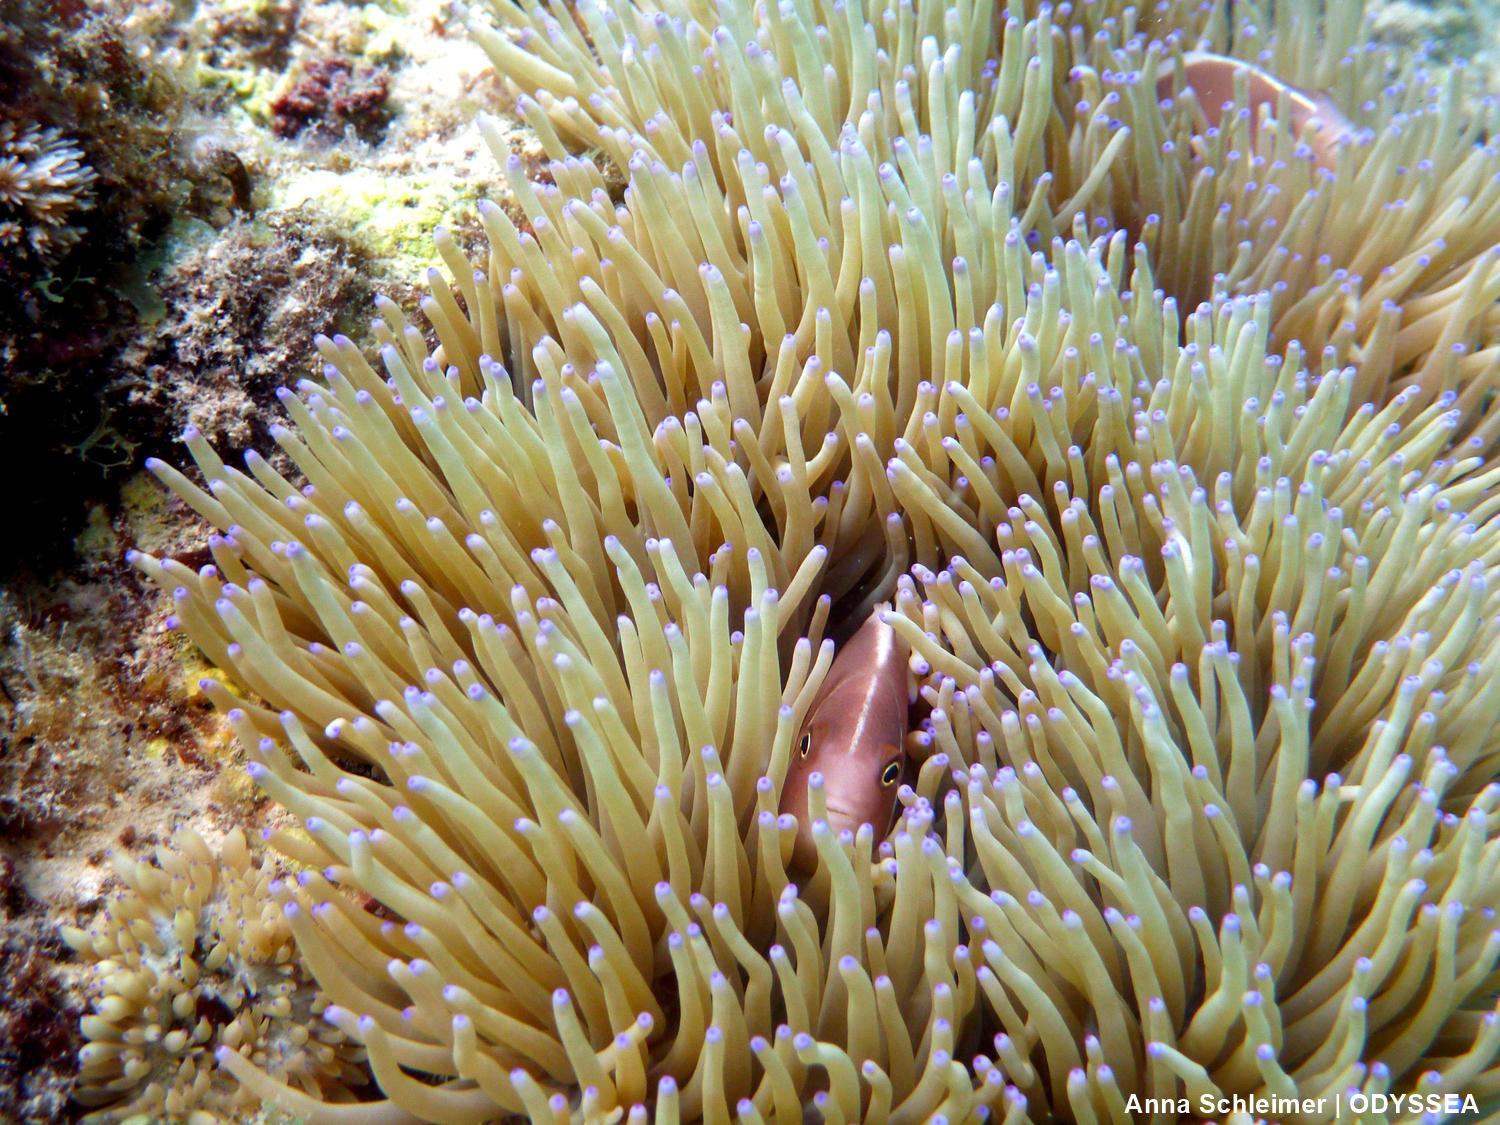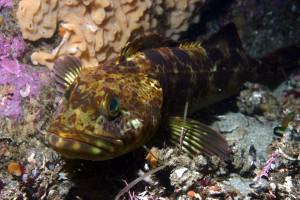The first image is the image on the left, the second image is the image on the right. For the images shown, is this caption "Fish and coral are shown." true? Answer yes or no. Yes. 